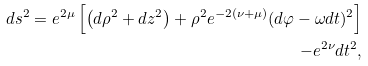Convert formula to latex. <formula><loc_0><loc_0><loc_500><loc_500>d s ^ { 2 } = e ^ { 2 \mu } \left [ \left ( d \rho ^ { 2 } + d z ^ { 2 } \right ) + \rho ^ { 2 } e ^ { - 2 ( \nu + \mu ) } ( d \varphi - \omega d t ) ^ { 2 } \right ] \\ - e ^ { 2 \nu } d t ^ { 2 } ,</formula> 